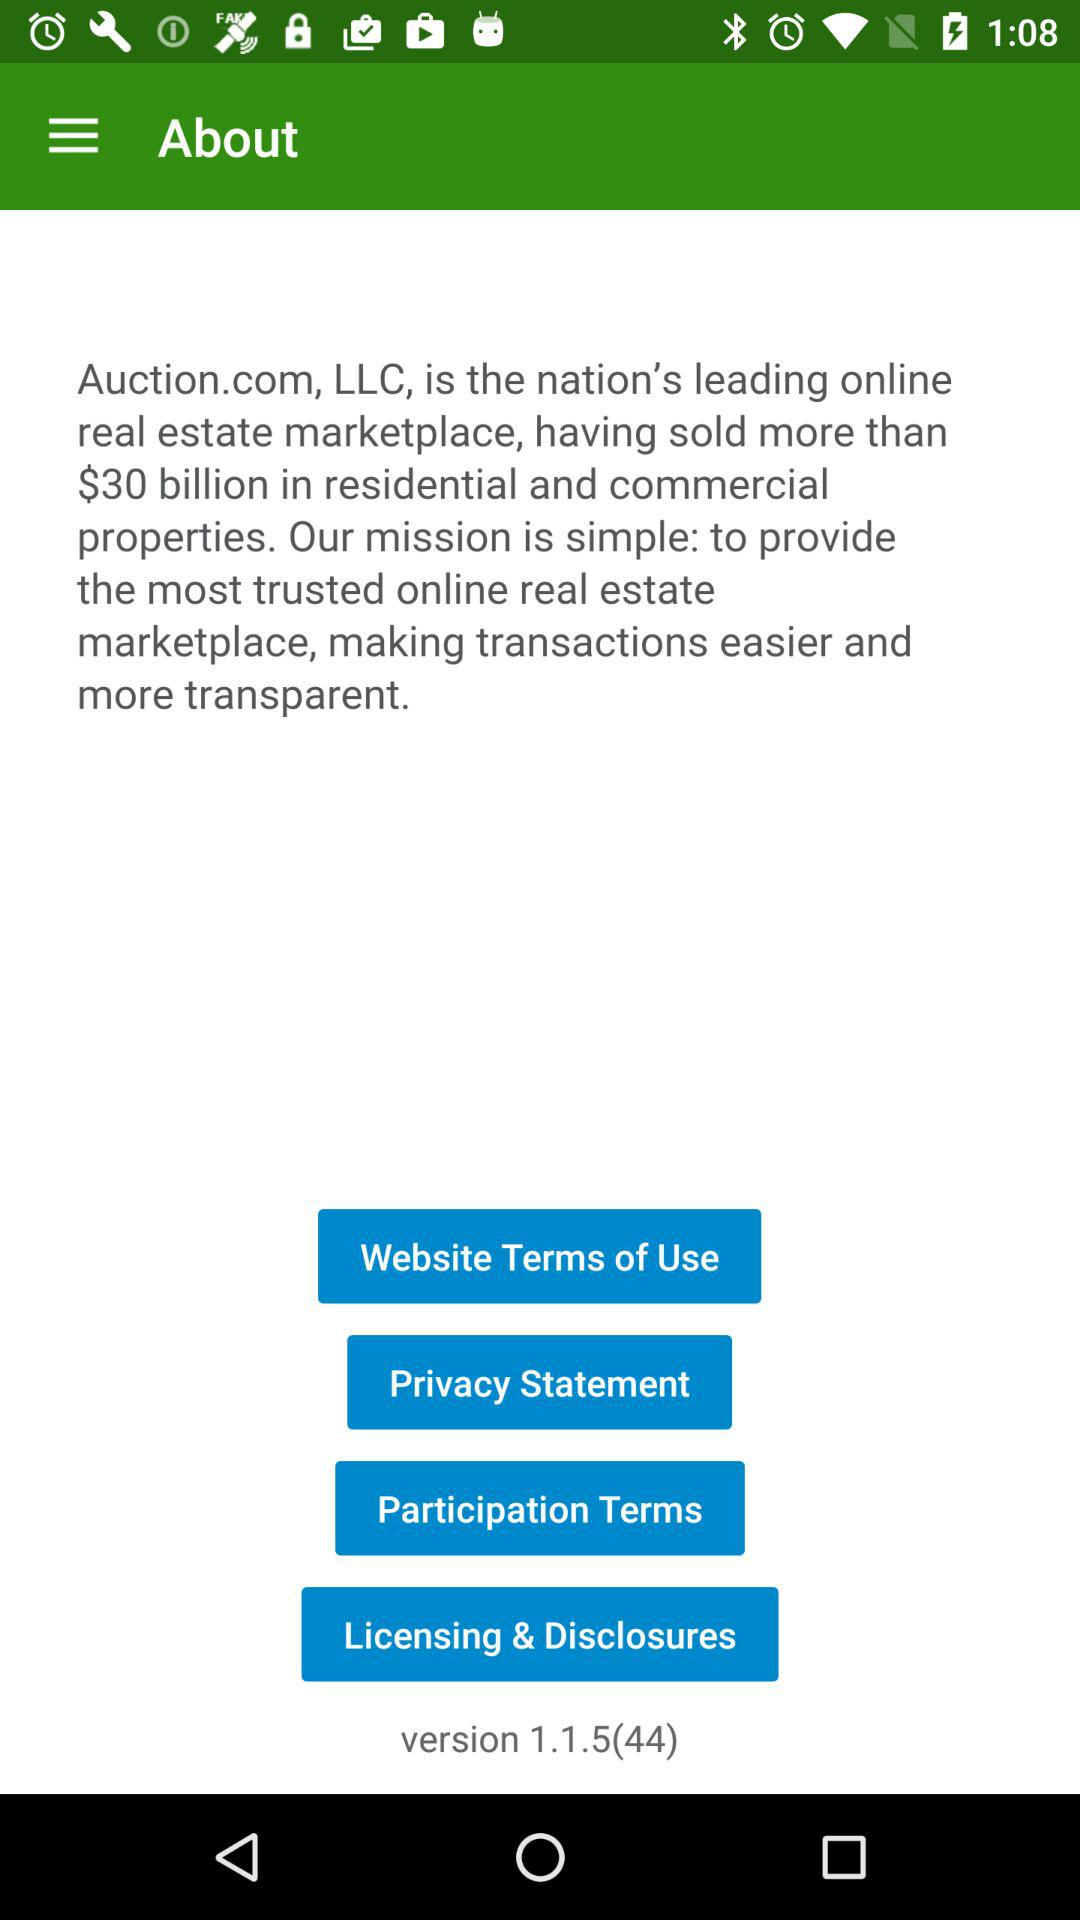What is the version? The version is 1.1.5(44). 